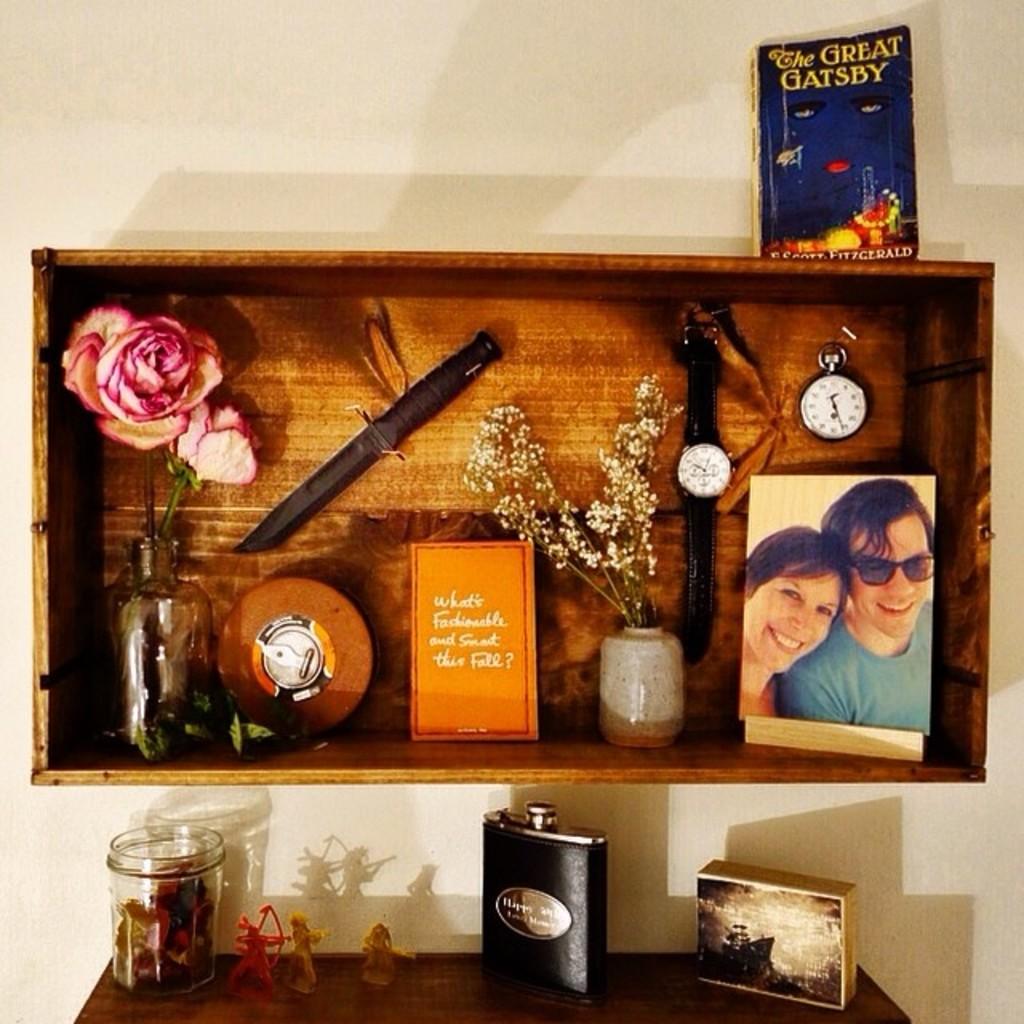What is the name of the book?
Offer a very short reply. The great gatsby. 